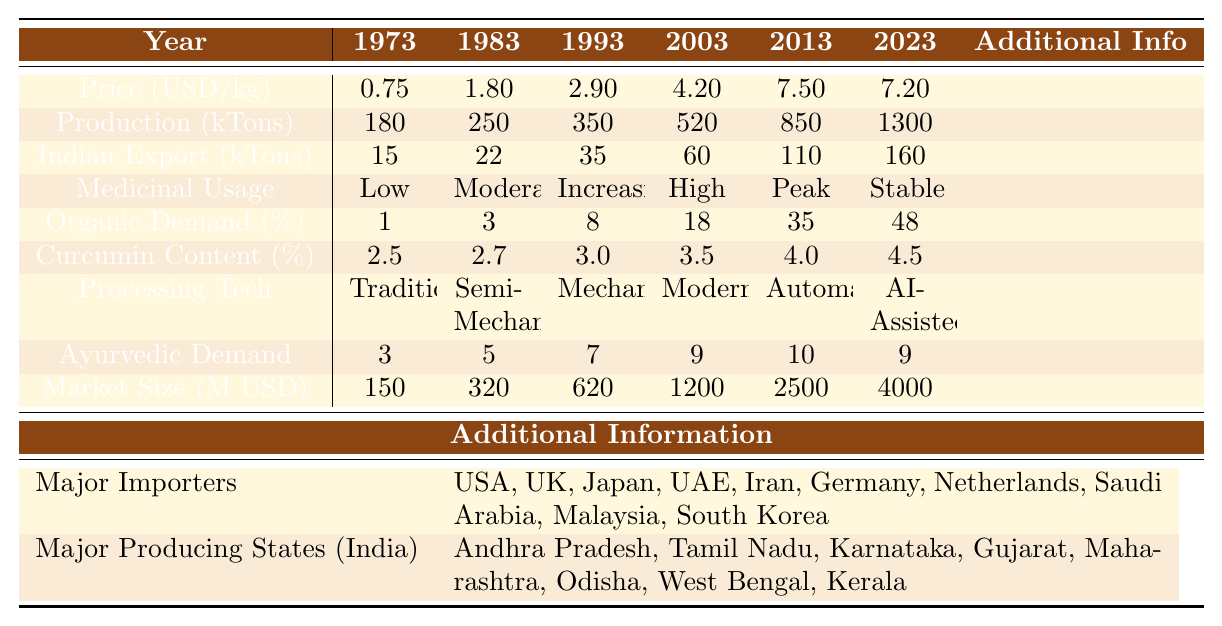What was the average price of turmeric in 1993? The table indicates the average price of turmeric in 1993 was listed under "Price (USD/kg)" corresponding to the year 1993, which is $2.90.
Answer: 2.90 What is the global production of turmeric in 2018? The global production value in 2018 can be found in the "Production (kTons)" row for the year 2018, which is 1,100,000 tons (or 1100 kTons).
Answer: 1100 By how much did the average price of turmeric increase from 1988 to 2003? The average price in 1988 was $2.25 and in 2003 it was $4.20. The difference is calculated as $4.20 - $2.25 = $1.95.
Answer: 1.95 Is there a trend of increasing medicinal usage from 1983 to 2013? By inspecting the "Medicinal Usage" row, the trend shows: Low in 1983, Moderate in 1988, Increasing in 1993, High in 1998, Peak in 2003, and Stable in 2013, indicating an overall increase during this period.
Answer: Yes What was the highest curcumin content percentage recorded in the table, and in which year was it reported? Looking at the "Curcumin Content (%)" row, the highest value is 4.5%, which is recorded in the year 2023.
Answer: 4.5% in 2023 How much did Indian exports of turmeric increase from 2008 to 2023? The Indian exports in 2008 were 85,000 tons and in 2023 they were 160,000 tons. The increase is calculated as 160 - 85 = 75 thousand tons.
Answer: 75 kTons Which major importer appeared in 2013 and remained until 2023? The major importers listed for 2013 were Malaysia and for 2023 it was South Korea. The importer common to both years is not found as Malaysia is only in 2013; thus, no overlap occurs.
Answer: No overlap What would be the average market size from 1973 to 2023? The average market size can be calculated by summing all market sizes from the table and dividing by the number of years. The sum is 150 + 220 + 320 + 450 + 620 + 850 + 1200 + 1800 + 2500 + 3200 + 4000 = 10,000 million USD and dividing by 11 gives approximately 909.09 million USD.
Answer: 909.09 million USD Was the organic demand for turmeric consistently increasing over the years? Reviewing the "Organic Demand (%)" row, the values are increasing from 1% in 1973 up to 48% in 2023 without any decrease in-between, showing a consistent upward trend.
Answer: Yes Considering the processing technology, when did turmeric production transition to fully automated systems? The "Processing Tech" row shows that fully automated technology was in place by 2018 and continued in 2023.
Answer: 2018 If the average price in 2013 was $7.50, what is the percentage decrease in price by 2018? The average price in 2018 was $6.80. The decrease is calculated as (7.50 - 6.80) / 7.50 × 100 = 9.33%.
Answer: 9.33% 